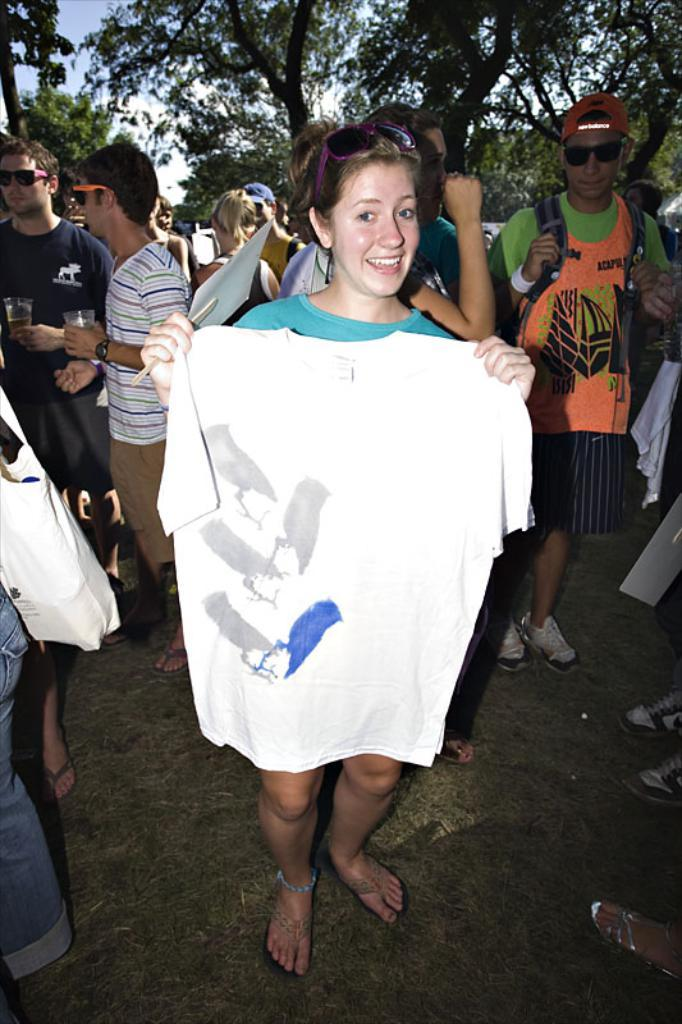How many people are present in the image? There are people in the image, but the exact number is not specified. What is the woman holding in the image? The woman is holding a t-shirt in the image. What accessory is the woman wearing? The woman is wearing glasses in the image. What can be seen in the background of the image? There are trees and the sky visible in the background of the image. What type of collar can be seen on the dog in the image? There is no dog present in the image, so no collar can be seen. 